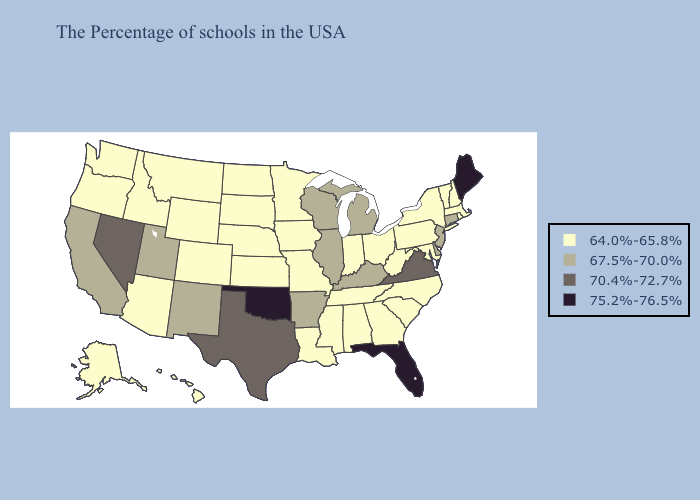Does the map have missing data?
Concise answer only. No. Among the states that border Kansas , does Colorado have the highest value?
Short answer required. No. Name the states that have a value in the range 70.4%-72.7%?
Answer briefly. Virginia, Texas, Nevada. What is the highest value in the West ?
Concise answer only. 70.4%-72.7%. Does the first symbol in the legend represent the smallest category?
Answer briefly. Yes. Which states hav the highest value in the West?
Answer briefly. Nevada. Name the states that have a value in the range 67.5%-70.0%?
Concise answer only. Connecticut, New Jersey, Delaware, Michigan, Kentucky, Wisconsin, Illinois, Arkansas, New Mexico, Utah, California. Which states have the lowest value in the West?
Quick response, please. Wyoming, Colorado, Montana, Arizona, Idaho, Washington, Oregon, Alaska, Hawaii. Which states hav the highest value in the MidWest?
Short answer required. Michigan, Wisconsin, Illinois. What is the value of Colorado?
Give a very brief answer. 64.0%-65.8%. What is the lowest value in the USA?
Quick response, please. 64.0%-65.8%. Does Illinois have the same value as Nebraska?
Keep it brief. No. What is the value of Maryland?
Write a very short answer. 64.0%-65.8%. Does Oregon have the highest value in the West?
Answer briefly. No. What is the value of Georgia?
Keep it brief. 64.0%-65.8%. 